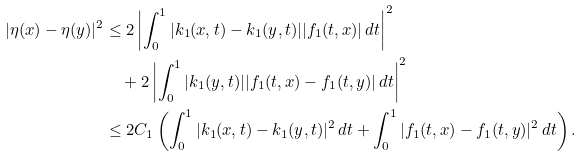Convert formula to latex. <formula><loc_0><loc_0><loc_500><loc_500>| \eta ( x ) - \eta ( y ) | ^ { 2 } & \leq 2 \left | \int _ { 0 } ^ { 1 } | k _ { 1 } ( x , t ) - k _ { 1 } ( y , t ) | | f _ { 1 } ( t , x ) | \, d t \right | ^ { 2 } \\ & \quad + 2 \left | \int _ { 0 } ^ { 1 } | k _ { 1 } ( y , t ) | | f _ { 1 } ( t , x ) - f _ { 1 } ( t , y ) | \, d t \right | ^ { 2 } \\ & \leq 2 C _ { 1 } \left ( \int _ { 0 } ^ { 1 } | k _ { 1 } ( x , t ) - k _ { 1 } ( y , t ) | ^ { 2 } \, d t + \int _ { 0 } ^ { 1 } | f _ { 1 } ( t , x ) - f _ { 1 } ( t , y ) | ^ { 2 } \, d t \right ) .</formula> 